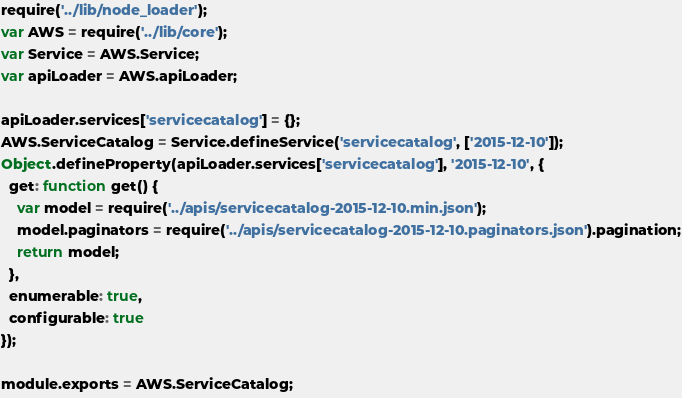Convert code to text. <code><loc_0><loc_0><loc_500><loc_500><_JavaScript_>require('../lib/node_loader');
var AWS = require('../lib/core');
var Service = AWS.Service;
var apiLoader = AWS.apiLoader;

apiLoader.services['servicecatalog'] = {};
AWS.ServiceCatalog = Service.defineService('servicecatalog', ['2015-12-10']);
Object.defineProperty(apiLoader.services['servicecatalog'], '2015-12-10', {
  get: function get() {
    var model = require('../apis/servicecatalog-2015-12-10.min.json');
    model.paginators = require('../apis/servicecatalog-2015-12-10.paginators.json').pagination;
    return model;
  },
  enumerable: true,
  configurable: true
});

module.exports = AWS.ServiceCatalog;
</code> 